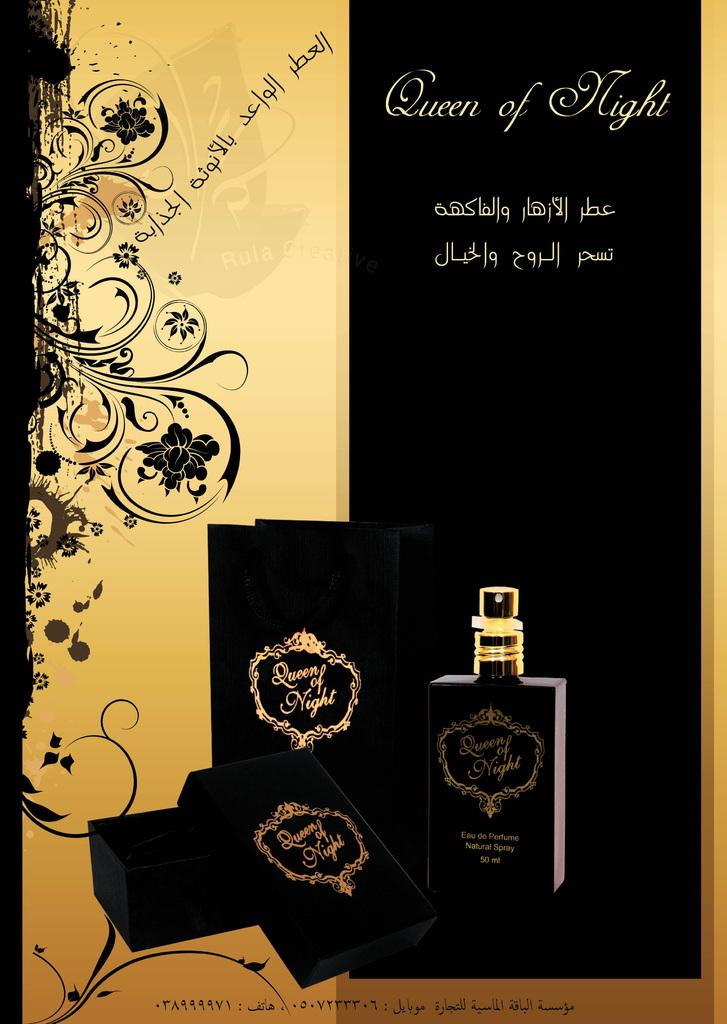<image>
Offer a succinct explanation of the picture presented. Ad for a perfume named Queen of Night. 